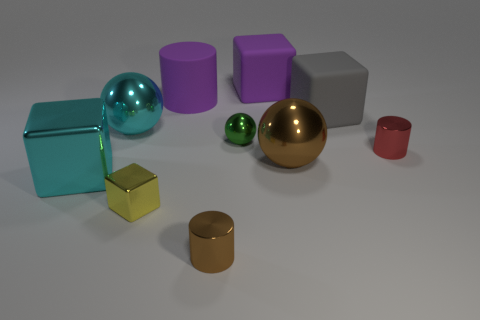How many gray things are to the right of the brown thing that is in front of the small metal cube? To the right of the brown cylindrical container, which is in front of the small golden metal cube, there is one single gray cube. 